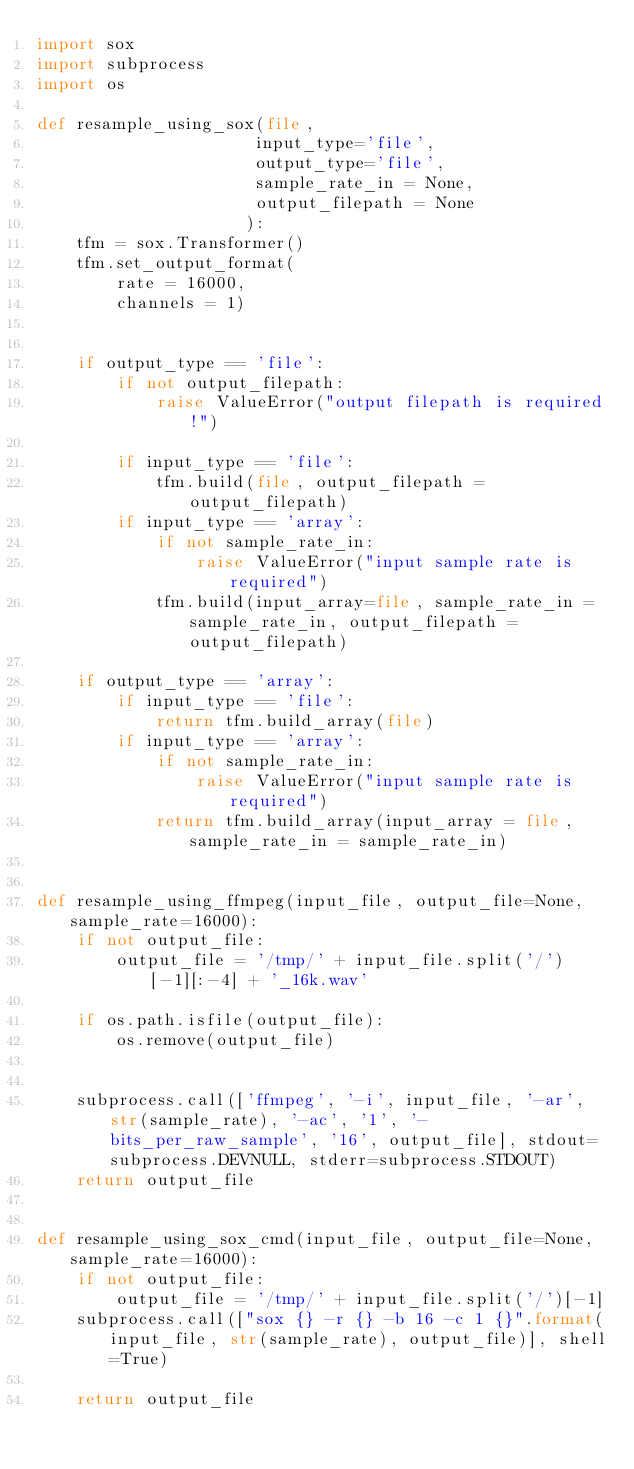Convert code to text. <code><loc_0><loc_0><loc_500><loc_500><_Python_>import sox
import subprocess
import os

def resample_using_sox(file, 
                      input_type='file', 
                      output_type='file',
                      sample_rate_in = None,
                      output_filepath = None
                     ):
    tfm = sox.Transformer()
    tfm.set_output_format(
        rate = 16000,
        channels = 1)
    
    
    if output_type == 'file':
        if not output_filepath:
            raise ValueError("output filepath is required!")
            
        if input_type == 'file':
            tfm.build(file, output_filepath = output_filepath)
        if input_type == 'array':
            if not sample_rate_in:
                raise ValueError("input sample rate is required")
            tfm.build(input_array=file, sample_rate_in = sample_rate_in, output_filepath = output_filepath)
        
    if output_type == 'array':
        if input_type == 'file':
            return tfm.build_array(file)
        if input_type == 'array':
            if not sample_rate_in:
                raise ValueError("input sample rate is required")
            return tfm.build_array(input_array = file,  sample_rate_in = sample_rate_in)
    

def resample_using_ffmpeg(input_file, output_file=None, sample_rate=16000):
    if not output_file:
        output_file = '/tmp/' + input_file.split('/')[-1][:-4] + '_16k.wav'

    if os.path.isfile(output_file):
        os.remove(output_file)


    subprocess.call(['ffmpeg', '-i', input_file, '-ar', str(sample_rate), '-ac', '1', '-bits_per_raw_sample', '16', output_file], stdout=subprocess.DEVNULL, stderr=subprocess.STDOUT)
    return output_file


def resample_using_sox_cmd(input_file, output_file=None, sample_rate=16000):
    if not output_file:
        output_file = '/tmp/' + input_file.split('/')[-1]
    subprocess.call(["sox {} -r {} -b 16 -c 1 {}".format(input_file, str(sample_rate), output_file)], shell=True)

    return output_file</code> 